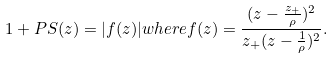<formula> <loc_0><loc_0><loc_500><loc_500>1 + P S ( z ) = | f ( z ) | w h e r e f ( z ) = \frac { ( z - \frac { z _ { + } } { \rho } ) ^ { 2 } } { z _ { + } ( z - \frac { 1 } { \rho } ) ^ { 2 } } .</formula> 